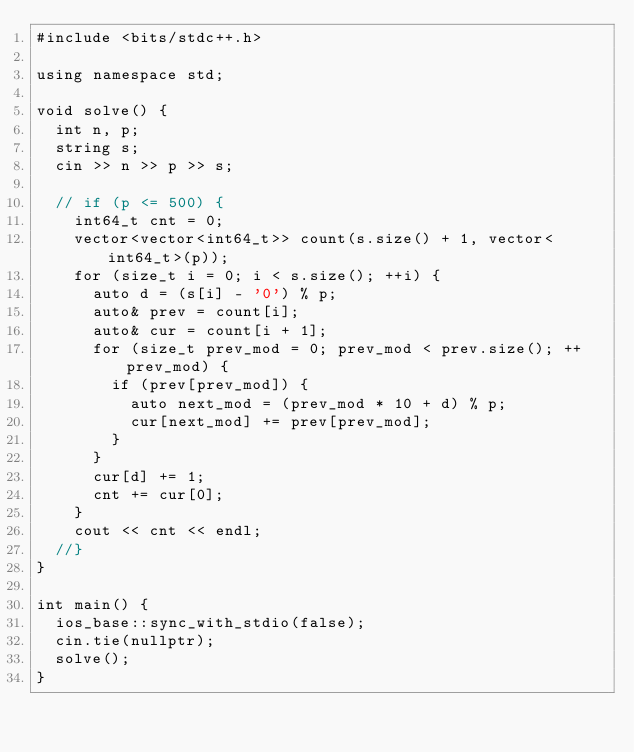<code> <loc_0><loc_0><loc_500><loc_500><_C++_>#include <bits/stdc++.h>

using namespace std;

void solve() {
  int n, p;
  string s;
  cin >> n >> p >> s;

  // if (p <= 500) {
    int64_t cnt = 0;
    vector<vector<int64_t>> count(s.size() + 1, vector<int64_t>(p));
    for (size_t i = 0; i < s.size(); ++i) {
      auto d = (s[i] - '0') % p;
      auto& prev = count[i];
      auto& cur = count[i + 1];
      for (size_t prev_mod = 0; prev_mod < prev.size(); ++prev_mod) {
        if (prev[prev_mod]) {
          auto next_mod = (prev_mod * 10 + d) % p;
          cur[next_mod] += prev[prev_mod];
        }
      }
      cur[d] += 1;
      cnt += cur[0];
    }
    cout << cnt << endl;
  //}
}

int main() {
  ios_base::sync_with_stdio(false);
  cin.tie(nullptr);
  solve();
}
</code> 